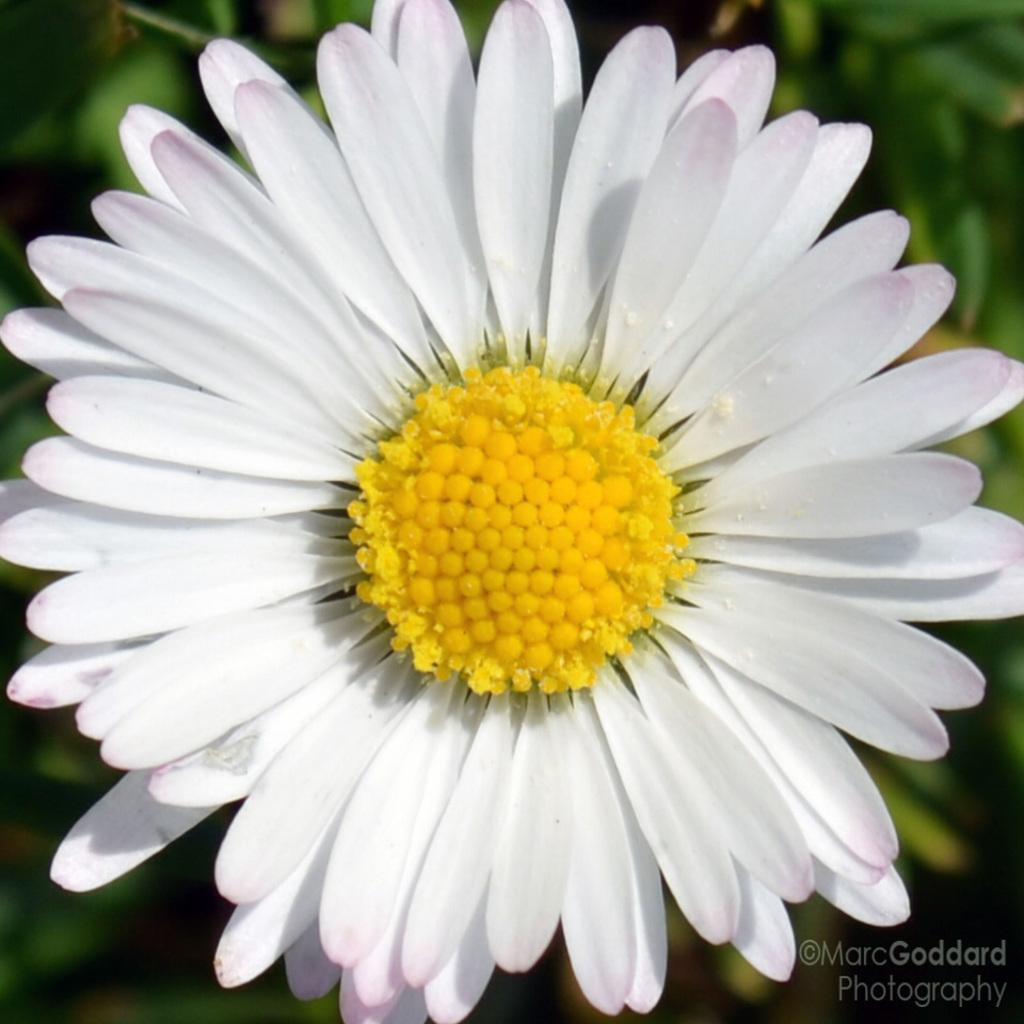What type of plant is featured in the image? There is a white-colored flower in the image. What else can be seen in the image besides the flower? There are leaves visible in the image. Is there any text or marking in the image? Yes, there is a watermark in the bottom right corner of the image. Can you tell me how many times the person in the image is playing the guitar? There is no person or guitar present in the image; it features a white-colored flower and leaves. 